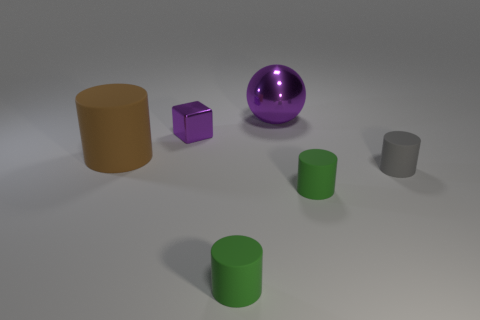Subtract 1 cylinders. How many cylinders are left? 3 Subtract all brown cylinders. How many cylinders are left? 3 Add 2 large balls. How many objects exist? 8 Subtract all cylinders. How many objects are left? 2 Subtract 0 blue spheres. How many objects are left? 6 Subtract all green things. Subtract all tiny blocks. How many objects are left? 3 Add 5 tiny gray rubber things. How many tiny gray rubber things are left? 6 Add 3 green cubes. How many green cubes exist? 3 